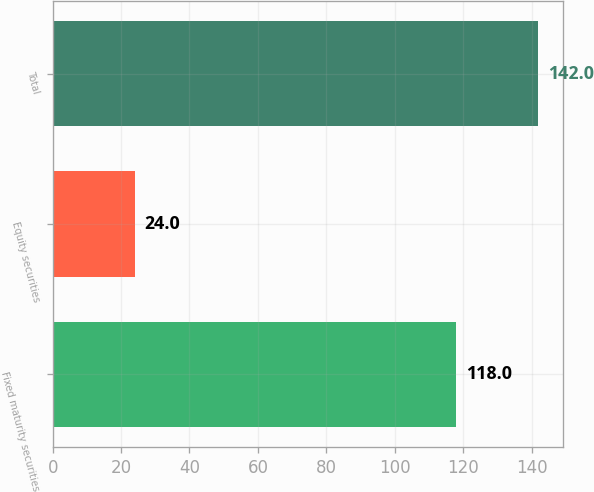Convert chart. <chart><loc_0><loc_0><loc_500><loc_500><bar_chart><fcel>Fixed maturity securities<fcel>Equity securities<fcel>Total<nl><fcel>118<fcel>24<fcel>142<nl></chart> 